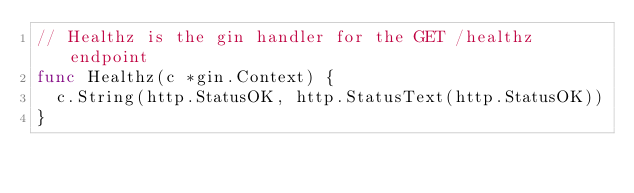Convert code to text. <code><loc_0><loc_0><loc_500><loc_500><_Go_>// Healthz is the gin handler for the GET /healthz endpoint
func Healthz(c *gin.Context) {
	c.String(http.StatusOK, http.StatusText(http.StatusOK))
}
</code> 